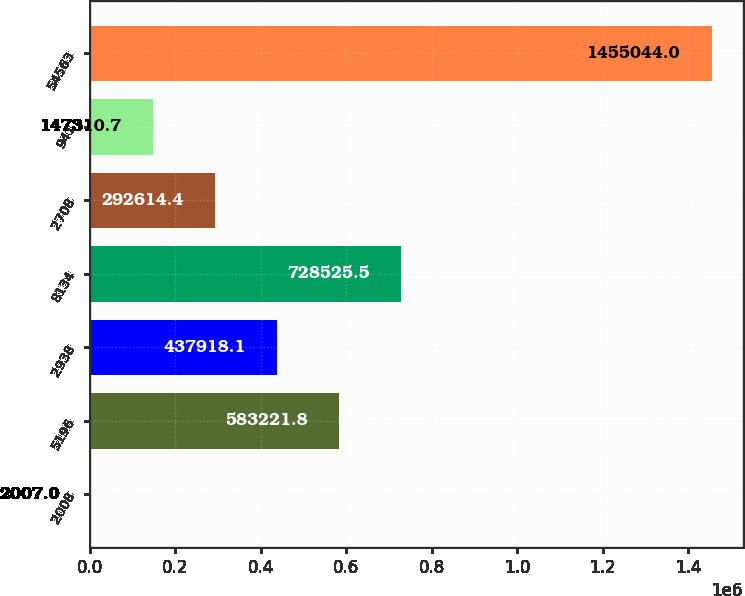Convert chart to OTSL. <chart><loc_0><loc_0><loc_500><loc_500><bar_chart><fcel>2008<fcel>5196<fcel>2938<fcel>8134<fcel>2708<fcel>941<fcel>54563<nl><fcel>2007<fcel>583222<fcel>437918<fcel>728526<fcel>292614<fcel>147311<fcel>1.45504e+06<nl></chart> 